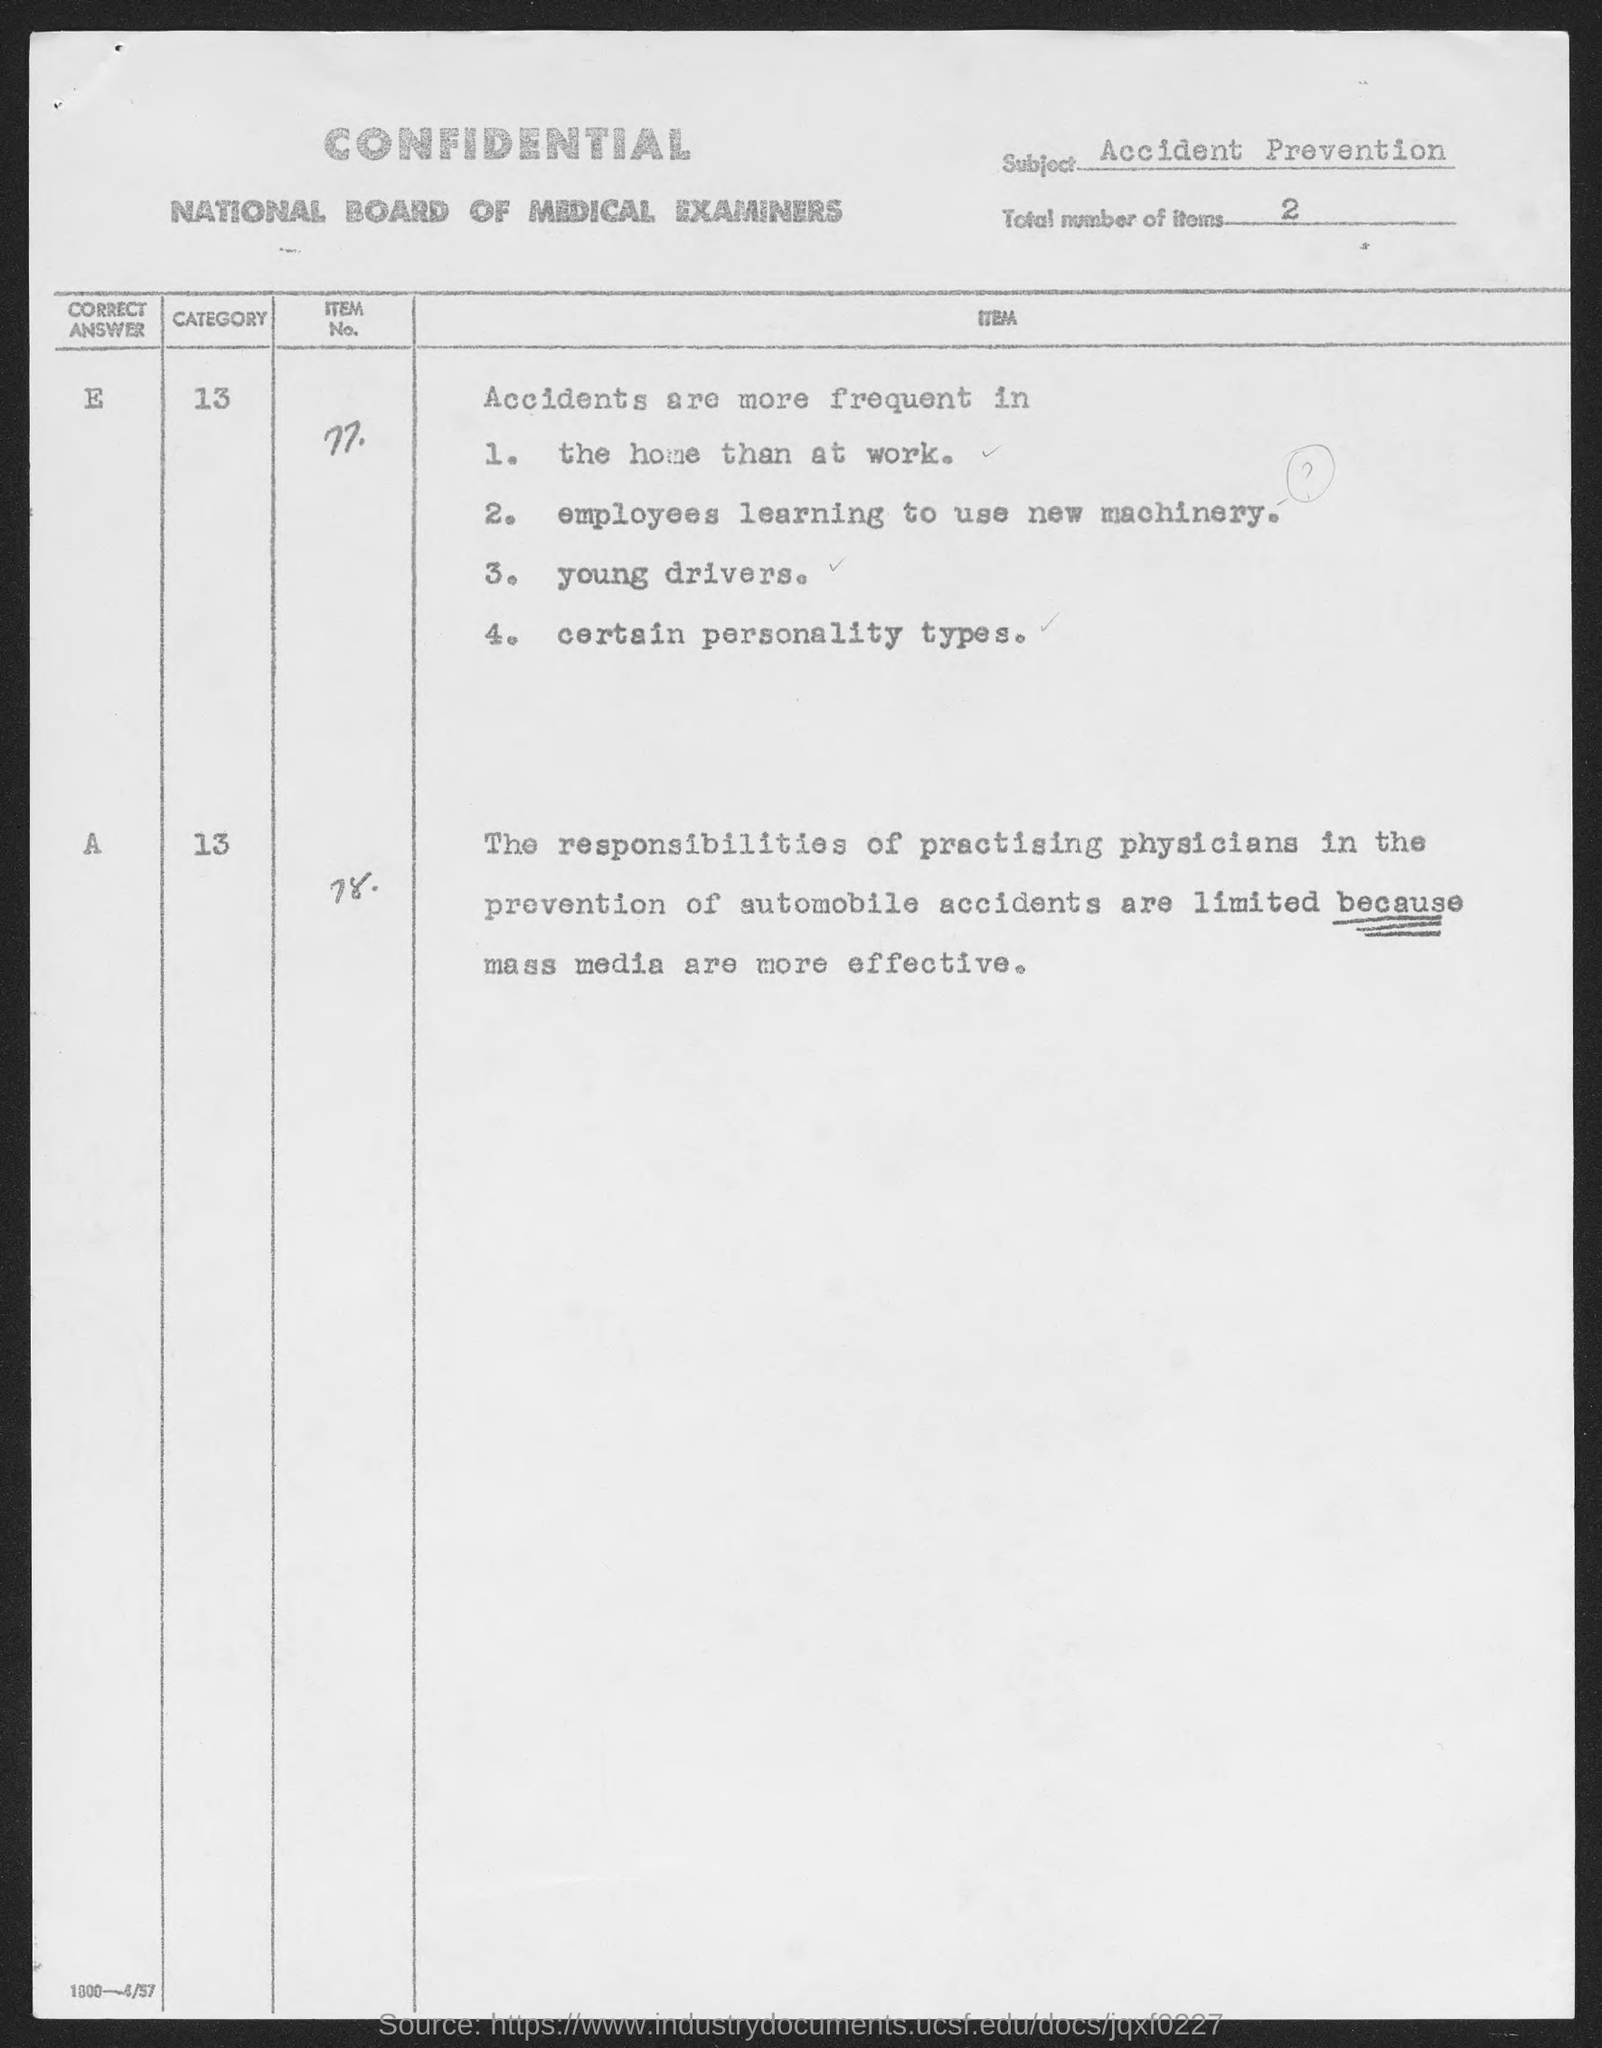Highlight a few significant elements in this photo. The subject name is Accident Prevention. Item no. 77 contains the third point which pertains to young drivers. The total number of items is 2. The second point in item no 77 is that employees are learning to use new machinery. The heading of the first column is "What is the heading of first column? Correct answer.. 